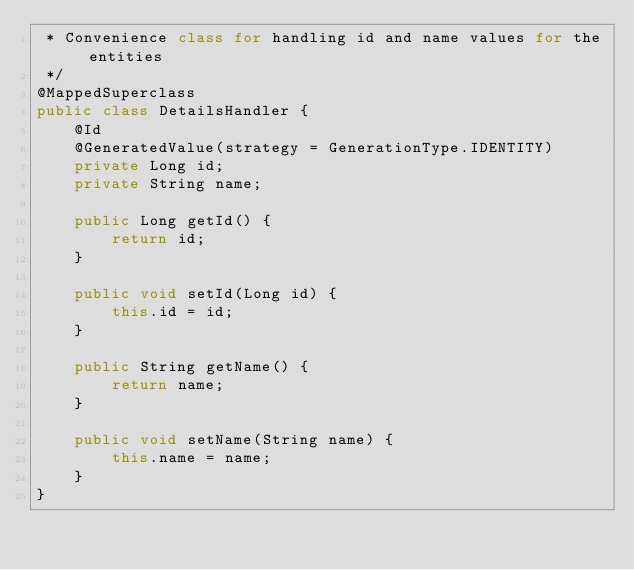<code> <loc_0><loc_0><loc_500><loc_500><_Java_> * Convenience class for handling id and name values for the entities
 */
@MappedSuperclass
public class DetailsHandler {
    @Id
    @GeneratedValue(strategy = GenerationType.IDENTITY)
    private Long id;
    private String name;

    public Long getId() {
        return id;
    }

    public void setId(Long id) {
        this.id = id;
    }

    public String getName() {
        return name;
    }

    public void setName(String name) {
        this.name = name;
    }
}
</code> 